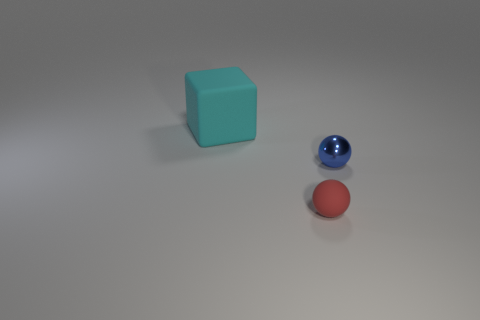Add 3 big yellow balls. How many objects exist? 6 Subtract all blocks. How many objects are left? 2 Subtract all large purple matte cubes. Subtract all red balls. How many objects are left? 2 Add 2 small red spheres. How many small red spheres are left? 3 Add 2 cyan blocks. How many cyan blocks exist? 3 Subtract 0 green cylinders. How many objects are left? 3 